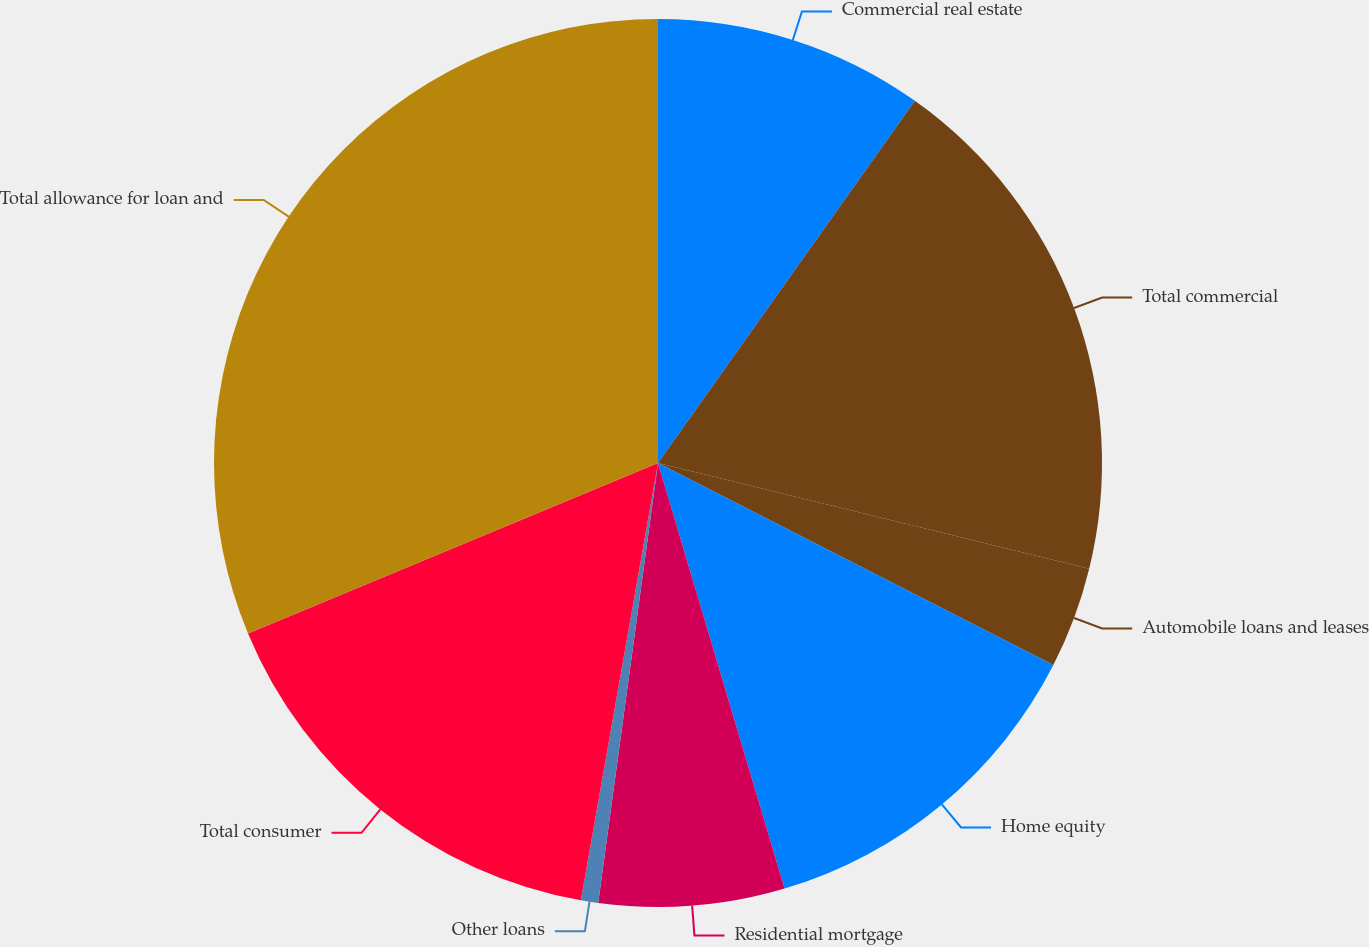Convert chart. <chart><loc_0><loc_0><loc_500><loc_500><pie_chart><fcel>Commercial real estate<fcel>Total commercial<fcel>Automobile loans and leases<fcel>Home equity<fcel>Residential mortgage<fcel>Other loans<fcel>Total consumer<fcel>Total allowance for loan and<nl><fcel>9.82%<fcel>19.01%<fcel>3.69%<fcel>12.88%<fcel>6.75%<fcel>0.63%<fcel>15.95%<fcel>31.27%<nl></chart> 